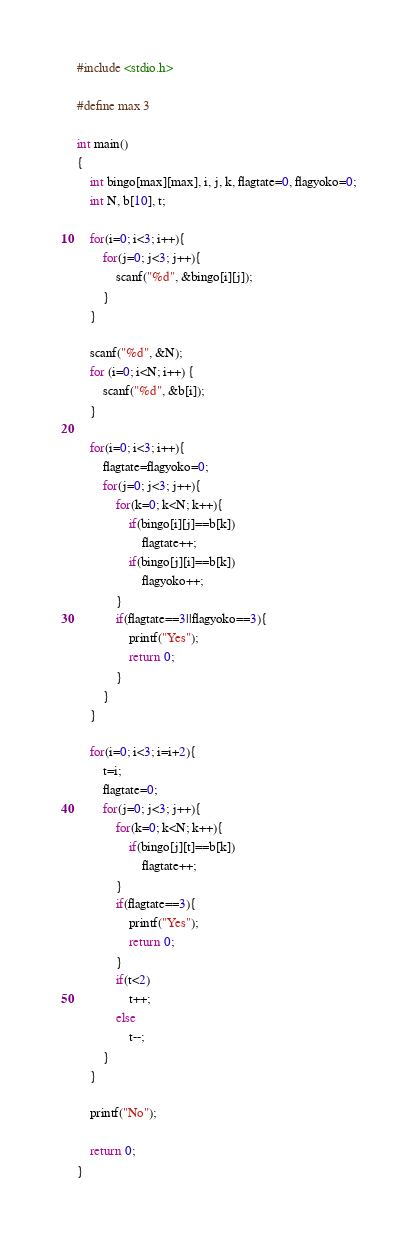Convert code to text. <code><loc_0><loc_0><loc_500><loc_500><_C_>#include <stdio.h>

#define max 3

int main()
{
    int bingo[max][max], i, j, k, flagtate=0, flagyoko=0;
    int N, b[10], t;
    
    for(i=0; i<3; i++){
        for(j=0; j<3; j++){
            scanf("%d", &bingo[i][j]);
        }
    }
    
    scanf("%d", &N);
    for (i=0; i<N; i++) {
        scanf("%d", &b[i]);
    }
    
    for(i=0; i<3; i++){
        flagtate=flagyoko=0;
        for(j=0; j<3; j++){
            for(k=0; k<N; k++){
                if(bingo[i][j]==b[k])
                    flagtate++;
                if(bingo[j][i]==b[k])
                    flagyoko++;
            }
            if(flagtate==3||flagyoko==3){
                printf("Yes");
                return 0;
            }
        }
    }

    for(i=0; i<3; i=i+2){
        t=i;
        flagtate=0;
        for(j=0; j<3; j++){
            for(k=0; k<N; k++){
                if(bingo[j][t]==b[k])
                    flagtate++;
            }
            if(flagtate==3){
                printf("Yes");
                return 0;
            }
            if(t<2)
                t++;
            else
                t--;
        }
    }
    
    printf("No");
    
    return 0;
}
</code> 